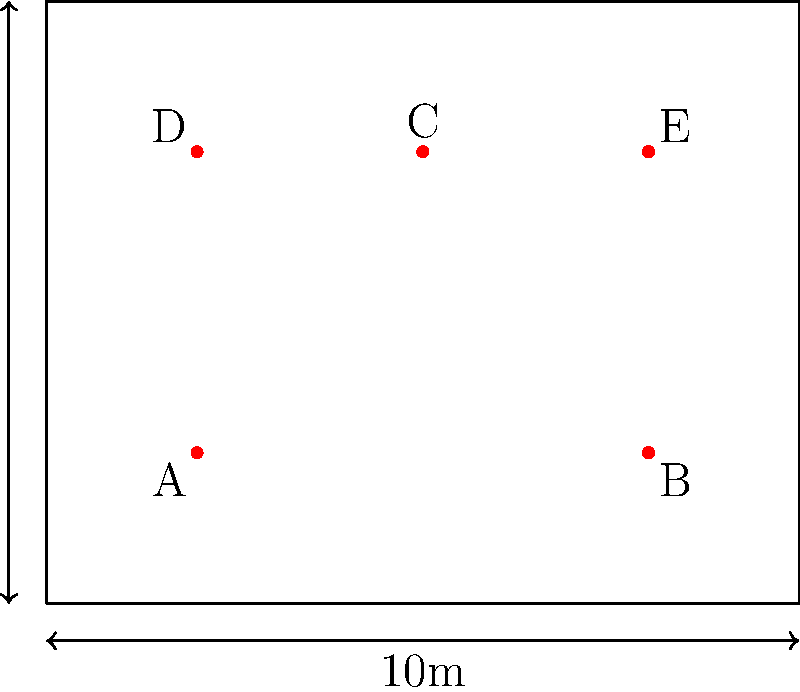Given the stage lighting grid shown above, where five lighting fixtures (A, B, C, D, and E) are positioned, calculate the total length of cable needed to connect all fixtures in the sequence A-B-C-D-E-A, assuming the cable runs along the grid lines. Express your answer in meters. To solve this problem, we need to calculate the distance between each pair of consecutively connected fixtures, following the grid lines. Let's break it down step by step:

1. A to B: 
   - Horizontal distance: 6m
   - Vertical distance: 0m
   - Total: 6m

2. B to C:
   - Horizontal distance: 3m
   - Vertical distance: 4m
   - Total: 3m + 4m = 7m

3. C to D:
   - Horizontal distance: 3m
   - Vertical distance: 0m
   - Total: 3m

4. D to E:
   - Horizontal distance: 6m
   - Vertical distance: 0m
   - Total: 6m

5. E to A (to complete the loop):
   - Horizontal distance: 6m
   - Vertical distance: 4m
   - Total: 6m + 4m = 10m

Now, we sum up all these distances:
$$\text{Total cable length} = 6 + 7 + 3 + 6 + 10 = 32\text{ meters}$$

Therefore, the total length of cable needed is 32 meters.
Answer: 32 meters 